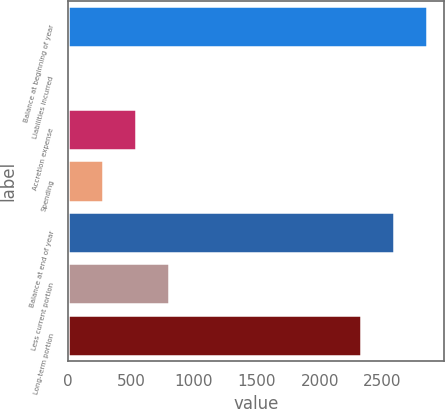<chart> <loc_0><loc_0><loc_500><loc_500><bar_chart><fcel>Balance at beginning of year<fcel>Liabilities incurred<fcel>Accretion expense<fcel>Spending<fcel>Balance at end of year<fcel>Less current portion<fcel>Long-term portion<nl><fcel>2850.2<fcel>14<fcel>538.2<fcel>276.1<fcel>2588.1<fcel>800.3<fcel>2326<nl></chart> 